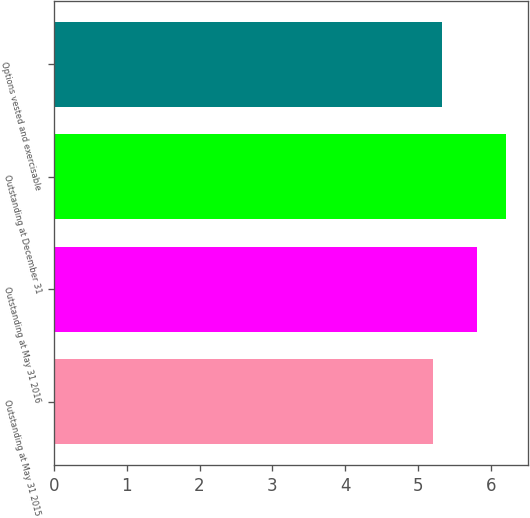Convert chart to OTSL. <chart><loc_0><loc_0><loc_500><loc_500><bar_chart><fcel>Outstanding at May 31 2015<fcel>Outstanding at May 31 2016<fcel>Outstanding at December 31<fcel>Options vested and exercisable<nl><fcel>5.2<fcel>5.8<fcel>6.2<fcel>5.32<nl></chart> 